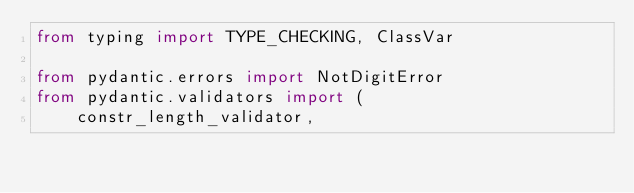<code> <loc_0><loc_0><loc_500><loc_500><_Python_>from typing import TYPE_CHECKING, ClassVar

from pydantic.errors import NotDigitError
from pydantic.validators import (
    constr_length_validator,</code> 